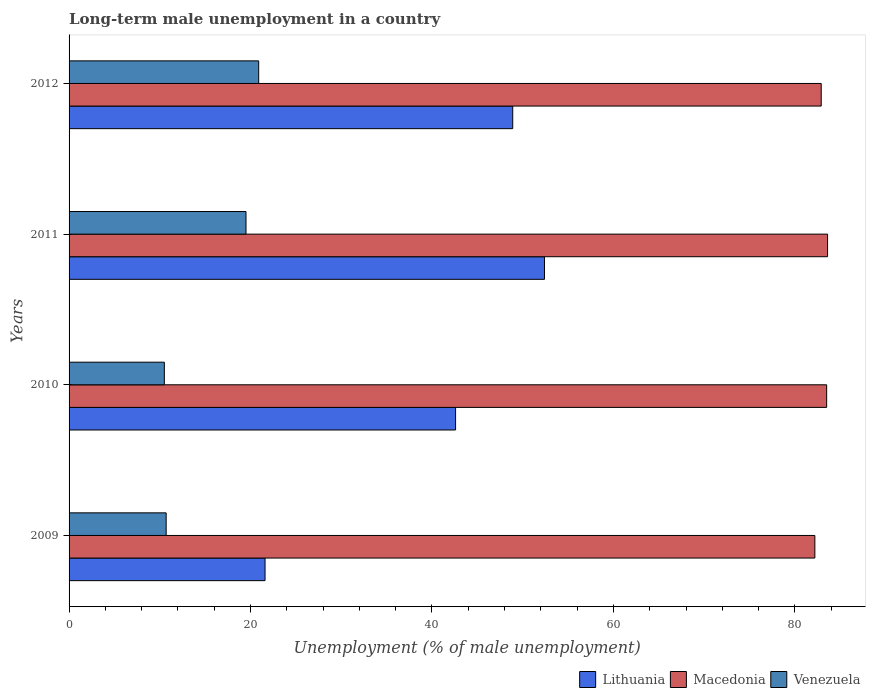How many groups of bars are there?
Make the answer very short. 4. Are the number of bars on each tick of the Y-axis equal?
Keep it short and to the point. Yes. How many bars are there on the 3rd tick from the top?
Your response must be concise. 3. What is the percentage of long-term unemployed male population in Lithuania in 2012?
Your answer should be very brief. 48.9. Across all years, what is the maximum percentage of long-term unemployed male population in Lithuania?
Your response must be concise. 52.4. Across all years, what is the minimum percentage of long-term unemployed male population in Macedonia?
Offer a terse response. 82.2. In which year was the percentage of long-term unemployed male population in Lithuania maximum?
Make the answer very short. 2011. In which year was the percentage of long-term unemployed male population in Venezuela minimum?
Make the answer very short. 2010. What is the total percentage of long-term unemployed male population in Lithuania in the graph?
Your answer should be compact. 165.5. What is the difference between the percentage of long-term unemployed male population in Macedonia in 2009 and that in 2011?
Provide a succinct answer. -1.4. What is the difference between the percentage of long-term unemployed male population in Macedonia in 2010 and the percentage of long-term unemployed male population in Lithuania in 2012?
Offer a very short reply. 34.6. What is the average percentage of long-term unemployed male population in Macedonia per year?
Offer a very short reply. 83.05. In the year 2009, what is the difference between the percentage of long-term unemployed male population in Venezuela and percentage of long-term unemployed male population in Macedonia?
Offer a terse response. -71.5. What is the ratio of the percentage of long-term unemployed male population in Venezuela in 2009 to that in 2011?
Provide a short and direct response. 0.55. Is the difference between the percentage of long-term unemployed male population in Venezuela in 2009 and 2012 greater than the difference between the percentage of long-term unemployed male population in Macedonia in 2009 and 2012?
Your answer should be compact. No. What is the difference between the highest and the second highest percentage of long-term unemployed male population in Macedonia?
Provide a succinct answer. 0.1. What is the difference between the highest and the lowest percentage of long-term unemployed male population in Venezuela?
Your response must be concise. 10.4. What does the 1st bar from the top in 2010 represents?
Ensure brevity in your answer.  Venezuela. What does the 3rd bar from the bottom in 2009 represents?
Your answer should be very brief. Venezuela. Is it the case that in every year, the sum of the percentage of long-term unemployed male population in Lithuania and percentage of long-term unemployed male population in Macedonia is greater than the percentage of long-term unemployed male population in Venezuela?
Offer a very short reply. Yes. How many bars are there?
Provide a short and direct response. 12. Are the values on the major ticks of X-axis written in scientific E-notation?
Provide a succinct answer. No. Does the graph contain any zero values?
Offer a very short reply. No. Does the graph contain grids?
Make the answer very short. No. Where does the legend appear in the graph?
Ensure brevity in your answer.  Bottom right. How are the legend labels stacked?
Your answer should be very brief. Horizontal. What is the title of the graph?
Make the answer very short. Long-term male unemployment in a country. What is the label or title of the X-axis?
Keep it short and to the point. Unemployment (% of male unemployment). What is the Unemployment (% of male unemployment) of Lithuania in 2009?
Ensure brevity in your answer.  21.6. What is the Unemployment (% of male unemployment) of Macedonia in 2009?
Your answer should be compact. 82.2. What is the Unemployment (% of male unemployment) in Venezuela in 2009?
Your response must be concise. 10.7. What is the Unemployment (% of male unemployment) in Lithuania in 2010?
Make the answer very short. 42.6. What is the Unemployment (% of male unemployment) of Macedonia in 2010?
Give a very brief answer. 83.5. What is the Unemployment (% of male unemployment) in Venezuela in 2010?
Keep it short and to the point. 10.5. What is the Unemployment (% of male unemployment) in Lithuania in 2011?
Your answer should be very brief. 52.4. What is the Unemployment (% of male unemployment) of Macedonia in 2011?
Your answer should be compact. 83.6. What is the Unemployment (% of male unemployment) of Venezuela in 2011?
Give a very brief answer. 19.5. What is the Unemployment (% of male unemployment) in Lithuania in 2012?
Your answer should be very brief. 48.9. What is the Unemployment (% of male unemployment) of Macedonia in 2012?
Ensure brevity in your answer.  82.9. What is the Unemployment (% of male unemployment) in Venezuela in 2012?
Offer a very short reply. 20.9. Across all years, what is the maximum Unemployment (% of male unemployment) in Lithuania?
Provide a short and direct response. 52.4. Across all years, what is the maximum Unemployment (% of male unemployment) of Macedonia?
Offer a terse response. 83.6. Across all years, what is the maximum Unemployment (% of male unemployment) of Venezuela?
Offer a very short reply. 20.9. Across all years, what is the minimum Unemployment (% of male unemployment) in Lithuania?
Provide a succinct answer. 21.6. Across all years, what is the minimum Unemployment (% of male unemployment) in Macedonia?
Ensure brevity in your answer.  82.2. What is the total Unemployment (% of male unemployment) in Lithuania in the graph?
Provide a succinct answer. 165.5. What is the total Unemployment (% of male unemployment) of Macedonia in the graph?
Provide a succinct answer. 332.2. What is the total Unemployment (% of male unemployment) of Venezuela in the graph?
Keep it short and to the point. 61.6. What is the difference between the Unemployment (% of male unemployment) in Lithuania in 2009 and that in 2010?
Your response must be concise. -21. What is the difference between the Unemployment (% of male unemployment) in Macedonia in 2009 and that in 2010?
Provide a succinct answer. -1.3. What is the difference between the Unemployment (% of male unemployment) in Lithuania in 2009 and that in 2011?
Your answer should be very brief. -30.8. What is the difference between the Unemployment (% of male unemployment) of Macedonia in 2009 and that in 2011?
Ensure brevity in your answer.  -1.4. What is the difference between the Unemployment (% of male unemployment) of Venezuela in 2009 and that in 2011?
Make the answer very short. -8.8. What is the difference between the Unemployment (% of male unemployment) in Lithuania in 2009 and that in 2012?
Keep it short and to the point. -27.3. What is the difference between the Unemployment (% of male unemployment) of Venezuela in 2009 and that in 2012?
Your response must be concise. -10.2. What is the difference between the Unemployment (% of male unemployment) of Lithuania in 2010 and that in 2011?
Ensure brevity in your answer.  -9.8. What is the difference between the Unemployment (% of male unemployment) in Macedonia in 2010 and that in 2011?
Your answer should be compact. -0.1. What is the difference between the Unemployment (% of male unemployment) in Macedonia in 2010 and that in 2012?
Give a very brief answer. 0.6. What is the difference between the Unemployment (% of male unemployment) in Venezuela in 2010 and that in 2012?
Your response must be concise. -10.4. What is the difference between the Unemployment (% of male unemployment) in Lithuania in 2011 and that in 2012?
Your answer should be compact. 3.5. What is the difference between the Unemployment (% of male unemployment) of Macedonia in 2011 and that in 2012?
Ensure brevity in your answer.  0.7. What is the difference between the Unemployment (% of male unemployment) of Venezuela in 2011 and that in 2012?
Offer a terse response. -1.4. What is the difference between the Unemployment (% of male unemployment) of Lithuania in 2009 and the Unemployment (% of male unemployment) of Macedonia in 2010?
Give a very brief answer. -61.9. What is the difference between the Unemployment (% of male unemployment) in Macedonia in 2009 and the Unemployment (% of male unemployment) in Venezuela in 2010?
Your answer should be very brief. 71.7. What is the difference between the Unemployment (% of male unemployment) in Lithuania in 2009 and the Unemployment (% of male unemployment) in Macedonia in 2011?
Your response must be concise. -62. What is the difference between the Unemployment (% of male unemployment) in Macedonia in 2009 and the Unemployment (% of male unemployment) in Venezuela in 2011?
Make the answer very short. 62.7. What is the difference between the Unemployment (% of male unemployment) in Lithuania in 2009 and the Unemployment (% of male unemployment) in Macedonia in 2012?
Offer a very short reply. -61.3. What is the difference between the Unemployment (% of male unemployment) of Macedonia in 2009 and the Unemployment (% of male unemployment) of Venezuela in 2012?
Your answer should be compact. 61.3. What is the difference between the Unemployment (% of male unemployment) of Lithuania in 2010 and the Unemployment (% of male unemployment) of Macedonia in 2011?
Give a very brief answer. -41. What is the difference between the Unemployment (% of male unemployment) in Lithuania in 2010 and the Unemployment (% of male unemployment) in Venezuela in 2011?
Ensure brevity in your answer.  23.1. What is the difference between the Unemployment (% of male unemployment) of Macedonia in 2010 and the Unemployment (% of male unemployment) of Venezuela in 2011?
Offer a terse response. 64. What is the difference between the Unemployment (% of male unemployment) in Lithuania in 2010 and the Unemployment (% of male unemployment) in Macedonia in 2012?
Your answer should be compact. -40.3. What is the difference between the Unemployment (% of male unemployment) in Lithuania in 2010 and the Unemployment (% of male unemployment) in Venezuela in 2012?
Provide a succinct answer. 21.7. What is the difference between the Unemployment (% of male unemployment) of Macedonia in 2010 and the Unemployment (% of male unemployment) of Venezuela in 2012?
Your answer should be very brief. 62.6. What is the difference between the Unemployment (% of male unemployment) in Lithuania in 2011 and the Unemployment (% of male unemployment) in Macedonia in 2012?
Keep it short and to the point. -30.5. What is the difference between the Unemployment (% of male unemployment) of Lithuania in 2011 and the Unemployment (% of male unemployment) of Venezuela in 2012?
Offer a terse response. 31.5. What is the difference between the Unemployment (% of male unemployment) in Macedonia in 2011 and the Unemployment (% of male unemployment) in Venezuela in 2012?
Provide a succinct answer. 62.7. What is the average Unemployment (% of male unemployment) of Lithuania per year?
Ensure brevity in your answer.  41.38. What is the average Unemployment (% of male unemployment) in Macedonia per year?
Offer a terse response. 83.05. In the year 2009, what is the difference between the Unemployment (% of male unemployment) of Lithuania and Unemployment (% of male unemployment) of Macedonia?
Your answer should be compact. -60.6. In the year 2009, what is the difference between the Unemployment (% of male unemployment) of Macedonia and Unemployment (% of male unemployment) of Venezuela?
Your response must be concise. 71.5. In the year 2010, what is the difference between the Unemployment (% of male unemployment) of Lithuania and Unemployment (% of male unemployment) of Macedonia?
Offer a very short reply. -40.9. In the year 2010, what is the difference between the Unemployment (% of male unemployment) of Lithuania and Unemployment (% of male unemployment) of Venezuela?
Your response must be concise. 32.1. In the year 2010, what is the difference between the Unemployment (% of male unemployment) of Macedonia and Unemployment (% of male unemployment) of Venezuela?
Your answer should be compact. 73. In the year 2011, what is the difference between the Unemployment (% of male unemployment) in Lithuania and Unemployment (% of male unemployment) in Macedonia?
Offer a terse response. -31.2. In the year 2011, what is the difference between the Unemployment (% of male unemployment) of Lithuania and Unemployment (% of male unemployment) of Venezuela?
Offer a terse response. 32.9. In the year 2011, what is the difference between the Unemployment (% of male unemployment) of Macedonia and Unemployment (% of male unemployment) of Venezuela?
Offer a terse response. 64.1. In the year 2012, what is the difference between the Unemployment (% of male unemployment) in Lithuania and Unemployment (% of male unemployment) in Macedonia?
Your answer should be compact. -34. In the year 2012, what is the difference between the Unemployment (% of male unemployment) of Lithuania and Unemployment (% of male unemployment) of Venezuela?
Keep it short and to the point. 28. What is the ratio of the Unemployment (% of male unemployment) in Lithuania in 2009 to that in 2010?
Give a very brief answer. 0.51. What is the ratio of the Unemployment (% of male unemployment) of Macedonia in 2009 to that in 2010?
Give a very brief answer. 0.98. What is the ratio of the Unemployment (% of male unemployment) in Lithuania in 2009 to that in 2011?
Offer a very short reply. 0.41. What is the ratio of the Unemployment (% of male unemployment) in Macedonia in 2009 to that in 2011?
Offer a very short reply. 0.98. What is the ratio of the Unemployment (% of male unemployment) in Venezuela in 2009 to that in 2011?
Provide a short and direct response. 0.55. What is the ratio of the Unemployment (% of male unemployment) of Lithuania in 2009 to that in 2012?
Your answer should be very brief. 0.44. What is the ratio of the Unemployment (% of male unemployment) in Macedonia in 2009 to that in 2012?
Provide a short and direct response. 0.99. What is the ratio of the Unemployment (% of male unemployment) in Venezuela in 2009 to that in 2012?
Offer a terse response. 0.51. What is the ratio of the Unemployment (% of male unemployment) of Lithuania in 2010 to that in 2011?
Your answer should be compact. 0.81. What is the ratio of the Unemployment (% of male unemployment) of Venezuela in 2010 to that in 2011?
Ensure brevity in your answer.  0.54. What is the ratio of the Unemployment (% of male unemployment) of Lithuania in 2010 to that in 2012?
Make the answer very short. 0.87. What is the ratio of the Unemployment (% of male unemployment) of Macedonia in 2010 to that in 2012?
Your answer should be very brief. 1.01. What is the ratio of the Unemployment (% of male unemployment) of Venezuela in 2010 to that in 2012?
Your response must be concise. 0.5. What is the ratio of the Unemployment (% of male unemployment) of Lithuania in 2011 to that in 2012?
Keep it short and to the point. 1.07. What is the ratio of the Unemployment (% of male unemployment) in Macedonia in 2011 to that in 2012?
Offer a very short reply. 1.01. What is the ratio of the Unemployment (% of male unemployment) of Venezuela in 2011 to that in 2012?
Keep it short and to the point. 0.93. What is the difference between the highest and the second highest Unemployment (% of male unemployment) in Venezuela?
Provide a succinct answer. 1.4. What is the difference between the highest and the lowest Unemployment (% of male unemployment) of Lithuania?
Your response must be concise. 30.8. What is the difference between the highest and the lowest Unemployment (% of male unemployment) of Macedonia?
Your response must be concise. 1.4. What is the difference between the highest and the lowest Unemployment (% of male unemployment) of Venezuela?
Provide a short and direct response. 10.4. 